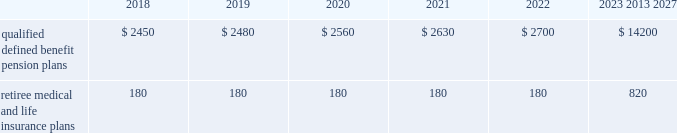U.s .
Equity securities and international equity securities categorized as level 1 are traded on active national and international exchanges and are valued at their closing prices on the last trading day of the year .
For u.s .
Equity securities and international equity securities not traded on an active exchange , or if the closing price is not available , the trustee obtains indicative quotes from a pricing vendor , broker or investment manager .
These securities are categorized as level 2 if the custodian obtains corroborated quotes from a pricing vendor or categorized as level 3 if the custodian obtains uncorroborated quotes from a broker or investment manager .
Commingled equity funds categorized as level 1 are traded on active national and international exchanges and are valued at their closing prices on the last trading day of the year .
For commingled equity funds not traded on an active exchange , or if the closing price is not available , the trustee obtains indicative quotes from a pricing vendor , broker or investment manager .
These securities are categorized as level 2 if the custodian obtains corroborated quotes from a pricing vendor .
Fixed income investments categorized as level 2 are valued by the trustee using pricing models that use verifiable observable market data ( e.g. , interest rates and yield curves observable at commonly quoted intervals and credit spreads ) , bids provided by brokers or dealers or quoted prices of securities with similar characteristics .
Fixed income investments are categorized at level 3 when valuations using observable inputs are unavailable .
The trustee obtains pricing based on indicative quotes or bid evaluations from vendors , brokers or the investment manager .
Commodities are traded on an active commodity exchange and are valued at their closing prices on the last trading day of the certain commingled equity funds , consisting of equity mutual funds , are valued using the nav.aa thenavaa valuations are based on the underlying investments and typically redeemable within 90 days .
Private equity funds consist of partnership and co-investment funds .
The navaa is based on valuation models of the underlying securities , which includes unobservable inputs that cannot be corroborated using verifiable observable market data .
These funds typically have redemption periods between eight and 12 years .
Real estate funds consist of partnerships , most of which are closed-end funds , for which the navaa is based on valuationmodels and periodic appraisals .
These funds typically have redemption periods between eight and 10 years .
Hedge funds consist of direct hedge funds forwhich thenavaa is generally based on the valuation of the underlying investments .
Redemptions in hedge funds are based on the specific terms of each fund , and generally range from a minimum of one month to several months .
Contributions and expected benefit payments the funding of our qualified defined benefit pension plans is determined in accordance with erisa , as amended by the ppa , and in a manner consistent with cas and internal revenue code rules .
There were no material contributions to our qualified defined benefit pension plans during 2017 .
We will make contributions of $ 5.0 billion to our qualified defined benefit pension plans in 2018 , including required and discretionary contributions.as a result of these contributions , we do not expect any material qualified defined benefit cash funding will be required until 2021.we plan to fund these contributions using a mix of cash on hand and commercial paper .
While we do not anticipate a need to do so , our capital structure and resources would allow us to issue new debt if circumstances change .
The table presents estimated future benefit payments , which reflect expected future employee service , as of december 31 , 2017 ( in millions ) : .
Defined contribution plans wemaintain a number of defined contribution plans , most with 401 ( k ) features , that cover substantially all of our employees .
Under the provisions of our 401 ( k ) plans , wematchmost employees 2019 eligible contributions at rates specified in the plan documents .
Our contributions were $ 613 million in 2017 , $ 617 million in 2016 and $ 393 million in 2015 , the majority of which were funded using our common stock .
Our defined contribution plans held approximately 35.5 million and 36.9 million shares of our common stock as of december 31 , 2017 and 2016. .
What is the change in millions of qualified defined benefit pension plans expected payments from 2018 to 2019? 
Computations: (2480 - 2450)
Answer: 30.0. 